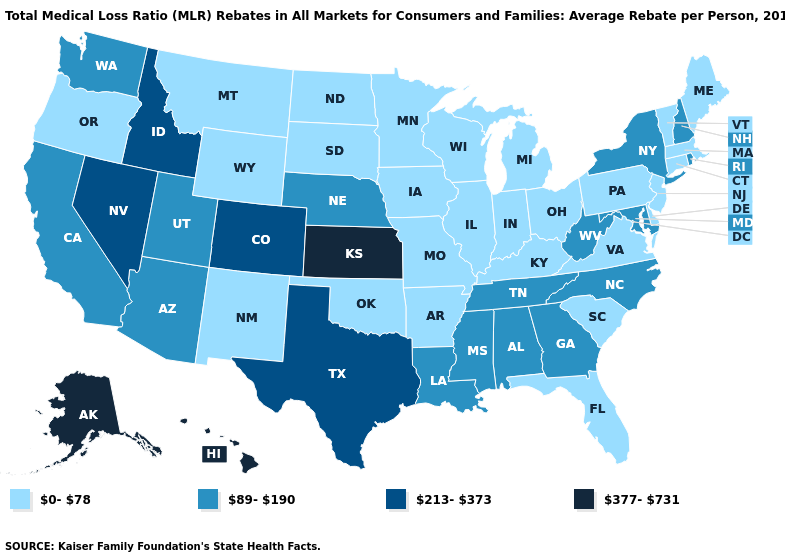Does the map have missing data?
Write a very short answer. No. Name the states that have a value in the range 213-373?
Short answer required. Colorado, Idaho, Nevada, Texas. Does the first symbol in the legend represent the smallest category?
Concise answer only. Yes. Name the states that have a value in the range 213-373?
Answer briefly. Colorado, Idaho, Nevada, Texas. Name the states that have a value in the range 89-190?
Answer briefly. Alabama, Arizona, California, Georgia, Louisiana, Maryland, Mississippi, Nebraska, New Hampshire, New York, North Carolina, Rhode Island, Tennessee, Utah, Washington, West Virginia. Is the legend a continuous bar?
Quick response, please. No. What is the lowest value in the MidWest?
Give a very brief answer. 0-78. Name the states that have a value in the range 213-373?
Write a very short answer. Colorado, Idaho, Nevada, Texas. What is the lowest value in states that border Iowa?
Be succinct. 0-78. Which states hav the highest value in the Northeast?
Answer briefly. New Hampshire, New York, Rhode Island. What is the value of New York?
Be succinct. 89-190. What is the value of Connecticut?
Write a very short answer. 0-78. What is the lowest value in states that border Kansas?
Quick response, please. 0-78. Does New Mexico have a higher value than Delaware?
Answer briefly. No. Does Connecticut have the lowest value in the USA?
Be succinct. Yes. 